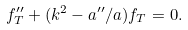Convert formula to latex. <formula><loc_0><loc_0><loc_500><loc_500>f _ { T } ^ { \prime \prime } + ( k ^ { 2 } - a ^ { \prime \prime } / a ) f _ { T } = 0 .</formula> 